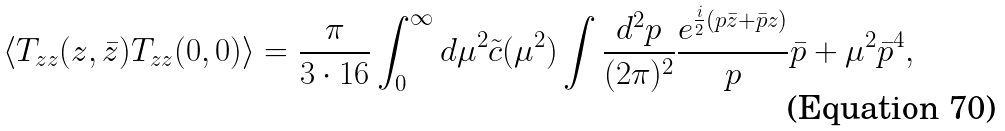Convert formula to latex. <formula><loc_0><loc_0><loc_500><loc_500>\langle T _ { z z } ( z , \bar { z } ) T _ { z z } ( 0 , 0 ) \rangle = \frac { \pi } { 3 \cdot 1 6 } \int _ { 0 } ^ { \infty } d \mu ^ { 2 } \tilde { c } ( \mu ^ { 2 } ) \int \frac { d ^ { 2 } p } { ( 2 \pi ) ^ { 2 } } \frac { e ^ { \frac { i } { 2 } ( p \bar { z } + \bar { p } z ) } } p \bar { p } + \mu ^ { 2 } \bar { p } ^ { 4 } ,</formula> 